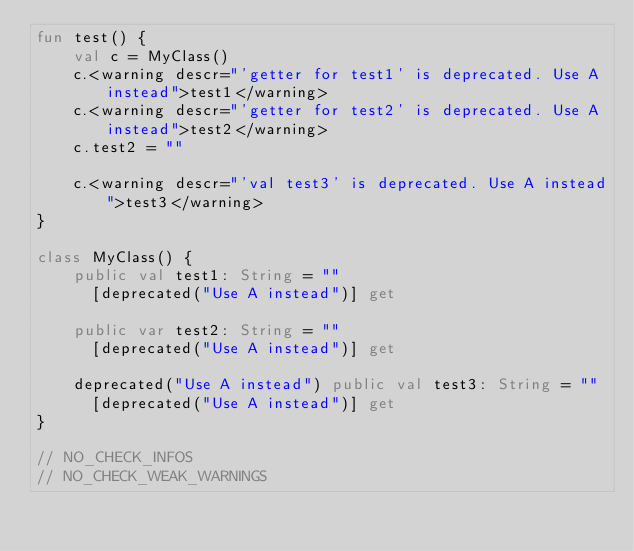Convert code to text. <code><loc_0><loc_0><loc_500><loc_500><_Kotlin_>fun test() {
    val c = MyClass()
    c.<warning descr="'getter for test1' is deprecated. Use A instead">test1</warning>
    c.<warning descr="'getter for test2' is deprecated. Use A instead">test2</warning>
    c.test2 = ""

    c.<warning descr="'val test3' is deprecated. Use A instead">test3</warning>
}

class MyClass() {
    public val test1: String = ""
      [deprecated("Use A instead")] get

    public var test2: String = ""
      [deprecated("Use A instead")] get

    deprecated("Use A instead") public val test3: String = ""
      [deprecated("Use A instead")] get
}

// NO_CHECK_INFOS
// NO_CHECK_WEAK_WARNINGS</code> 